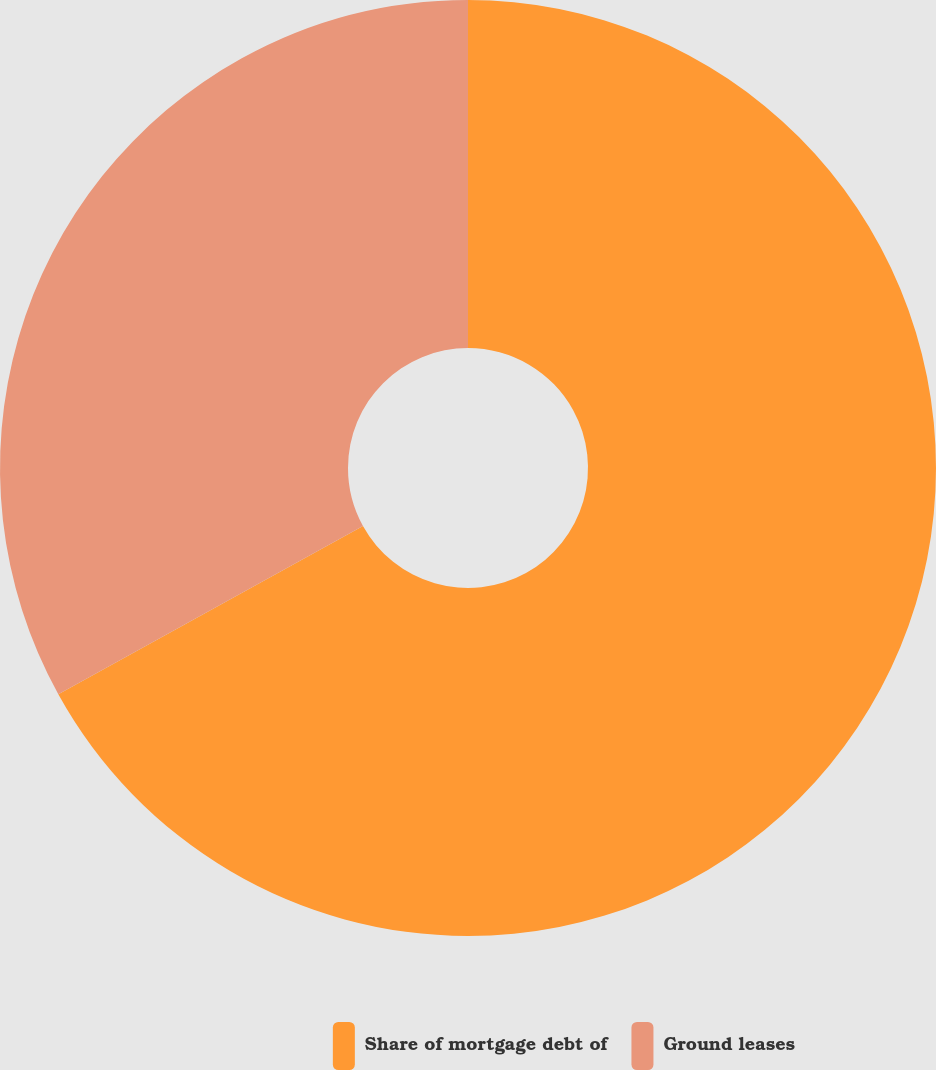Convert chart to OTSL. <chart><loc_0><loc_0><loc_500><loc_500><pie_chart><fcel>Share of mortgage debt of<fcel>Ground leases<nl><fcel>66.97%<fcel>33.03%<nl></chart> 